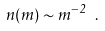<formula> <loc_0><loc_0><loc_500><loc_500>n ( m ) \sim m ^ { - 2 } \ .</formula> 